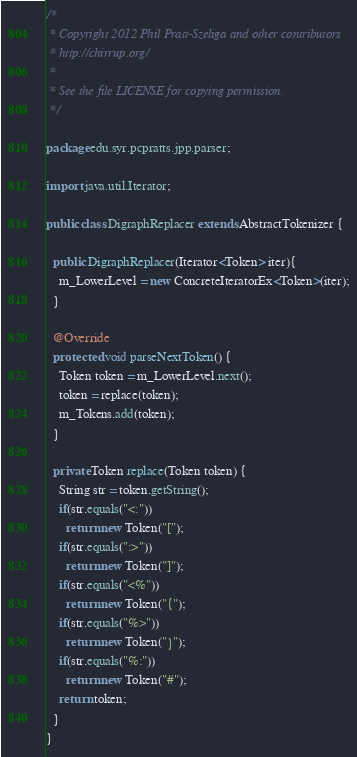Convert code to text. <code><loc_0><loc_0><loc_500><loc_500><_Java_>/* 
 * Copyright 2012 Phil Pratt-Szeliga and other contributors
 * http://chirrup.org/
 * 
 * See the file LICENSE for copying permission.
 */

package edu.syr.pcpratts.jpp.parser;

import java.util.Iterator;

public class DigraphReplacer extends AbstractTokenizer {

  public DigraphReplacer(Iterator<Token> iter){
    m_LowerLevel = new ConcreteIteratorEx<Token>(iter);
  }

  @Override
  protected void parseNextToken() {
    Token token = m_LowerLevel.next();
    token = replace(token);
    m_Tokens.add(token);
  }

  private Token replace(Token token) {
    String str = token.getString();
    if(str.equals("<:"))
      return new Token("[");
    if(str.equals(":>"))
      return new Token("]");
    if(str.equals("<%"))
      return new Token("{");
    if(str.equals("%>"))
      return new Token("}");
    if(str.equals("%:"))
      return new Token("#");
    return token;
  }
}
</code> 